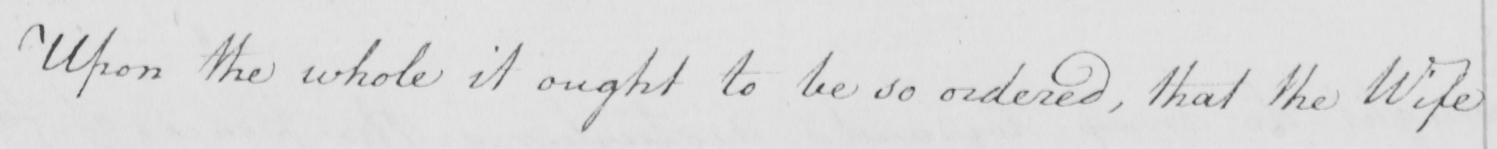What text is written in this handwritten line? Upon the whole it ought to be so ordered , that the Wife 